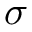<formula> <loc_0><loc_0><loc_500><loc_500>\sigma</formula> 